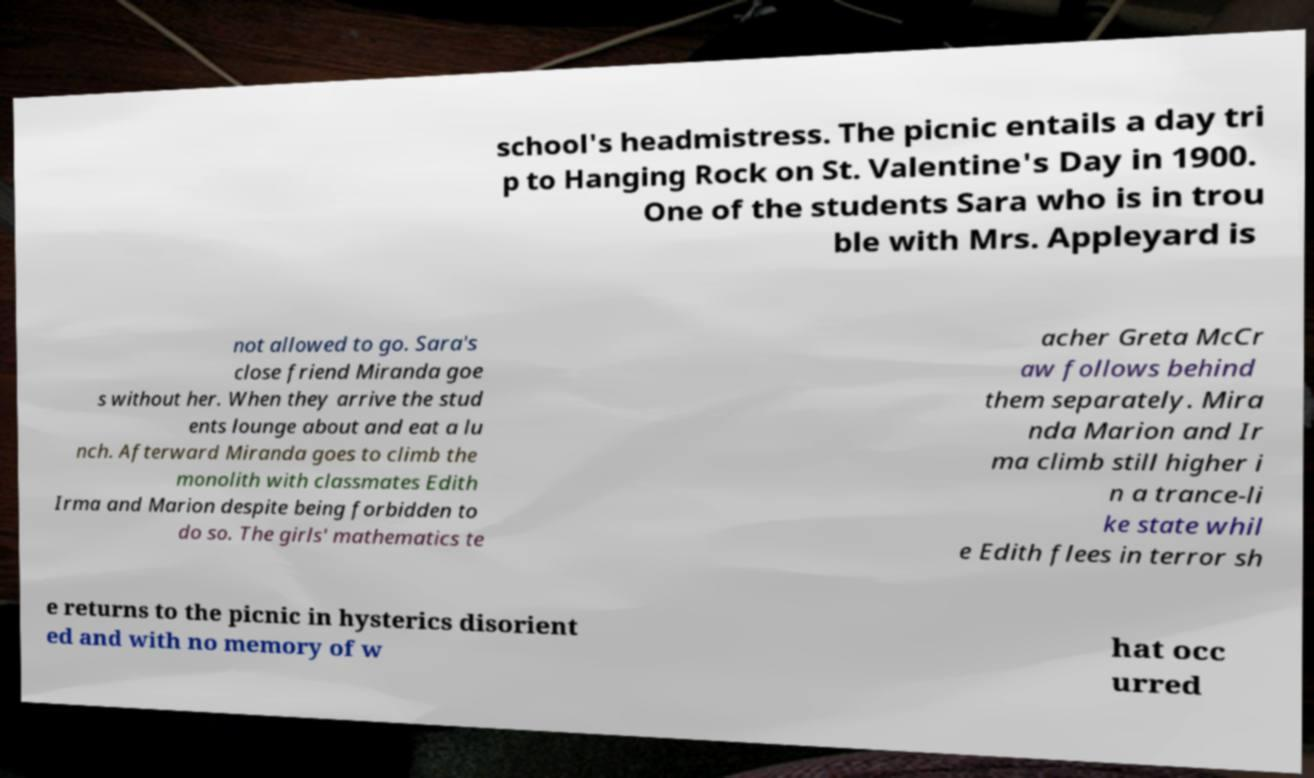Can you read and provide the text displayed in the image?This photo seems to have some interesting text. Can you extract and type it out for me? school's headmistress. The picnic entails a day tri p to Hanging Rock on St. Valentine's Day in 1900. One of the students Sara who is in trou ble with Mrs. Appleyard is not allowed to go. Sara's close friend Miranda goe s without her. When they arrive the stud ents lounge about and eat a lu nch. Afterward Miranda goes to climb the monolith with classmates Edith Irma and Marion despite being forbidden to do so. The girls' mathematics te acher Greta McCr aw follows behind them separately. Mira nda Marion and Ir ma climb still higher i n a trance-li ke state whil e Edith flees in terror sh e returns to the picnic in hysterics disorient ed and with no memory of w hat occ urred 